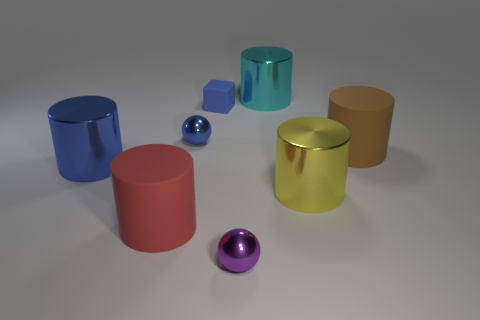Do the cyan thing and the blue metallic sphere have the same size? No, they do not have the same size. Upon closer inspection, the cyan cylinder appears to be slightly larger in height than the blue metallic sphere's diameter. 